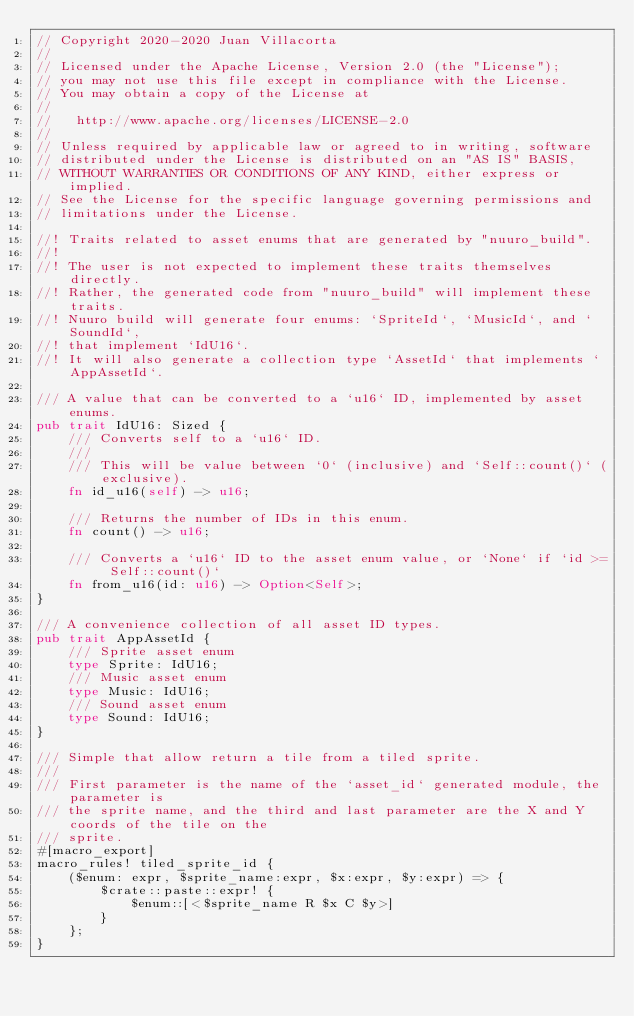<code> <loc_0><loc_0><loc_500><loc_500><_Rust_>// Copyright 2020-2020 Juan Villacorta
//
// Licensed under the Apache License, Version 2.0 (the "License");
// you may not use this file except in compliance with the License.
// You may obtain a copy of the License at
//
//   http://www.apache.org/licenses/LICENSE-2.0
//
// Unless required by applicable law or agreed to in writing, software
// distributed under the License is distributed on an "AS IS" BASIS,
// WITHOUT WARRANTIES OR CONDITIONS OF ANY KIND, either express or implied.
// See the License for the specific language governing permissions and
// limitations under the License.

//! Traits related to asset enums that are generated by "nuuro_build".
//!
//! The user is not expected to implement these traits themselves directly.
//! Rather, the generated code from "nuuro_build" will implement these traits.
//! Nuuro build will generate four enums: `SpriteId`, `MusicId`, and `SoundId`,
//! that implement `IdU16`.
//! It will also generate a collection type `AssetId` that implements `AppAssetId`.

/// A value that can be converted to a `u16` ID, implemented by asset enums.
pub trait IdU16: Sized {
    /// Converts self to a `u16` ID.
    ///
    /// This will be value between `0` (inclusive) and `Self::count()` (exclusive).
    fn id_u16(self) -> u16;

    /// Returns the number of IDs in this enum.
    fn count() -> u16;

    /// Converts a `u16` ID to the asset enum value, or `None` if `id >= Self::count()`
    fn from_u16(id: u16) -> Option<Self>;
}

/// A convenience collection of all asset ID types.
pub trait AppAssetId {
    /// Sprite asset enum
    type Sprite: IdU16;
    /// Music asset enum
    type Music: IdU16;
    /// Sound asset enum
    type Sound: IdU16;
}

/// Simple that allow return a tile from a tiled sprite.
///
/// First parameter is the name of the `asset_id` generated module, the parameter is
/// the sprite name, and the third and last parameter are the X and Y coords of the tile on the
/// sprite.
#[macro_export]
macro_rules! tiled_sprite_id {
    ($enum: expr, $sprite_name:expr, $x:expr, $y:expr) => {
        $crate::paste::expr! {
            $enum::[<$sprite_name R $x C $y>]
        }
    };
}
</code> 